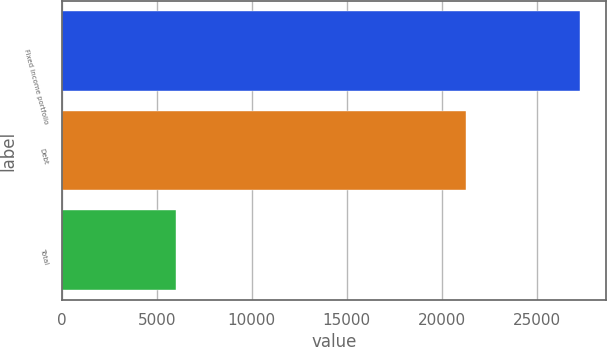<chart> <loc_0><loc_0><loc_500><loc_500><bar_chart><fcel>Fixed income portfolio<fcel>Debt<fcel>Total<nl><fcel>27299<fcel>21300<fcel>5999<nl></chart> 